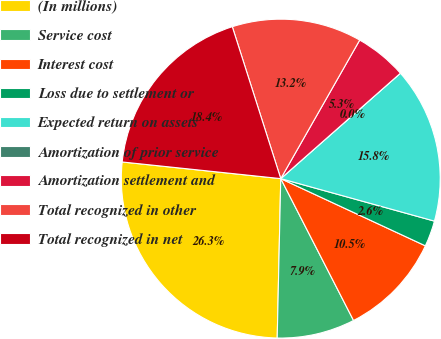Convert chart. <chart><loc_0><loc_0><loc_500><loc_500><pie_chart><fcel>(In millions)<fcel>Service cost<fcel>Interest cost<fcel>Loss due to settlement or<fcel>Expected return on assets<fcel>Amortization of prior service<fcel>Amortization settlement and<fcel>Total recognized in other<fcel>Total recognized in net<nl><fcel>26.31%<fcel>7.9%<fcel>10.53%<fcel>2.63%<fcel>15.79%<fcel>0.0%<fcel>5.26%<fcel>13.16%<fcel>18.42%<nl></chart> 